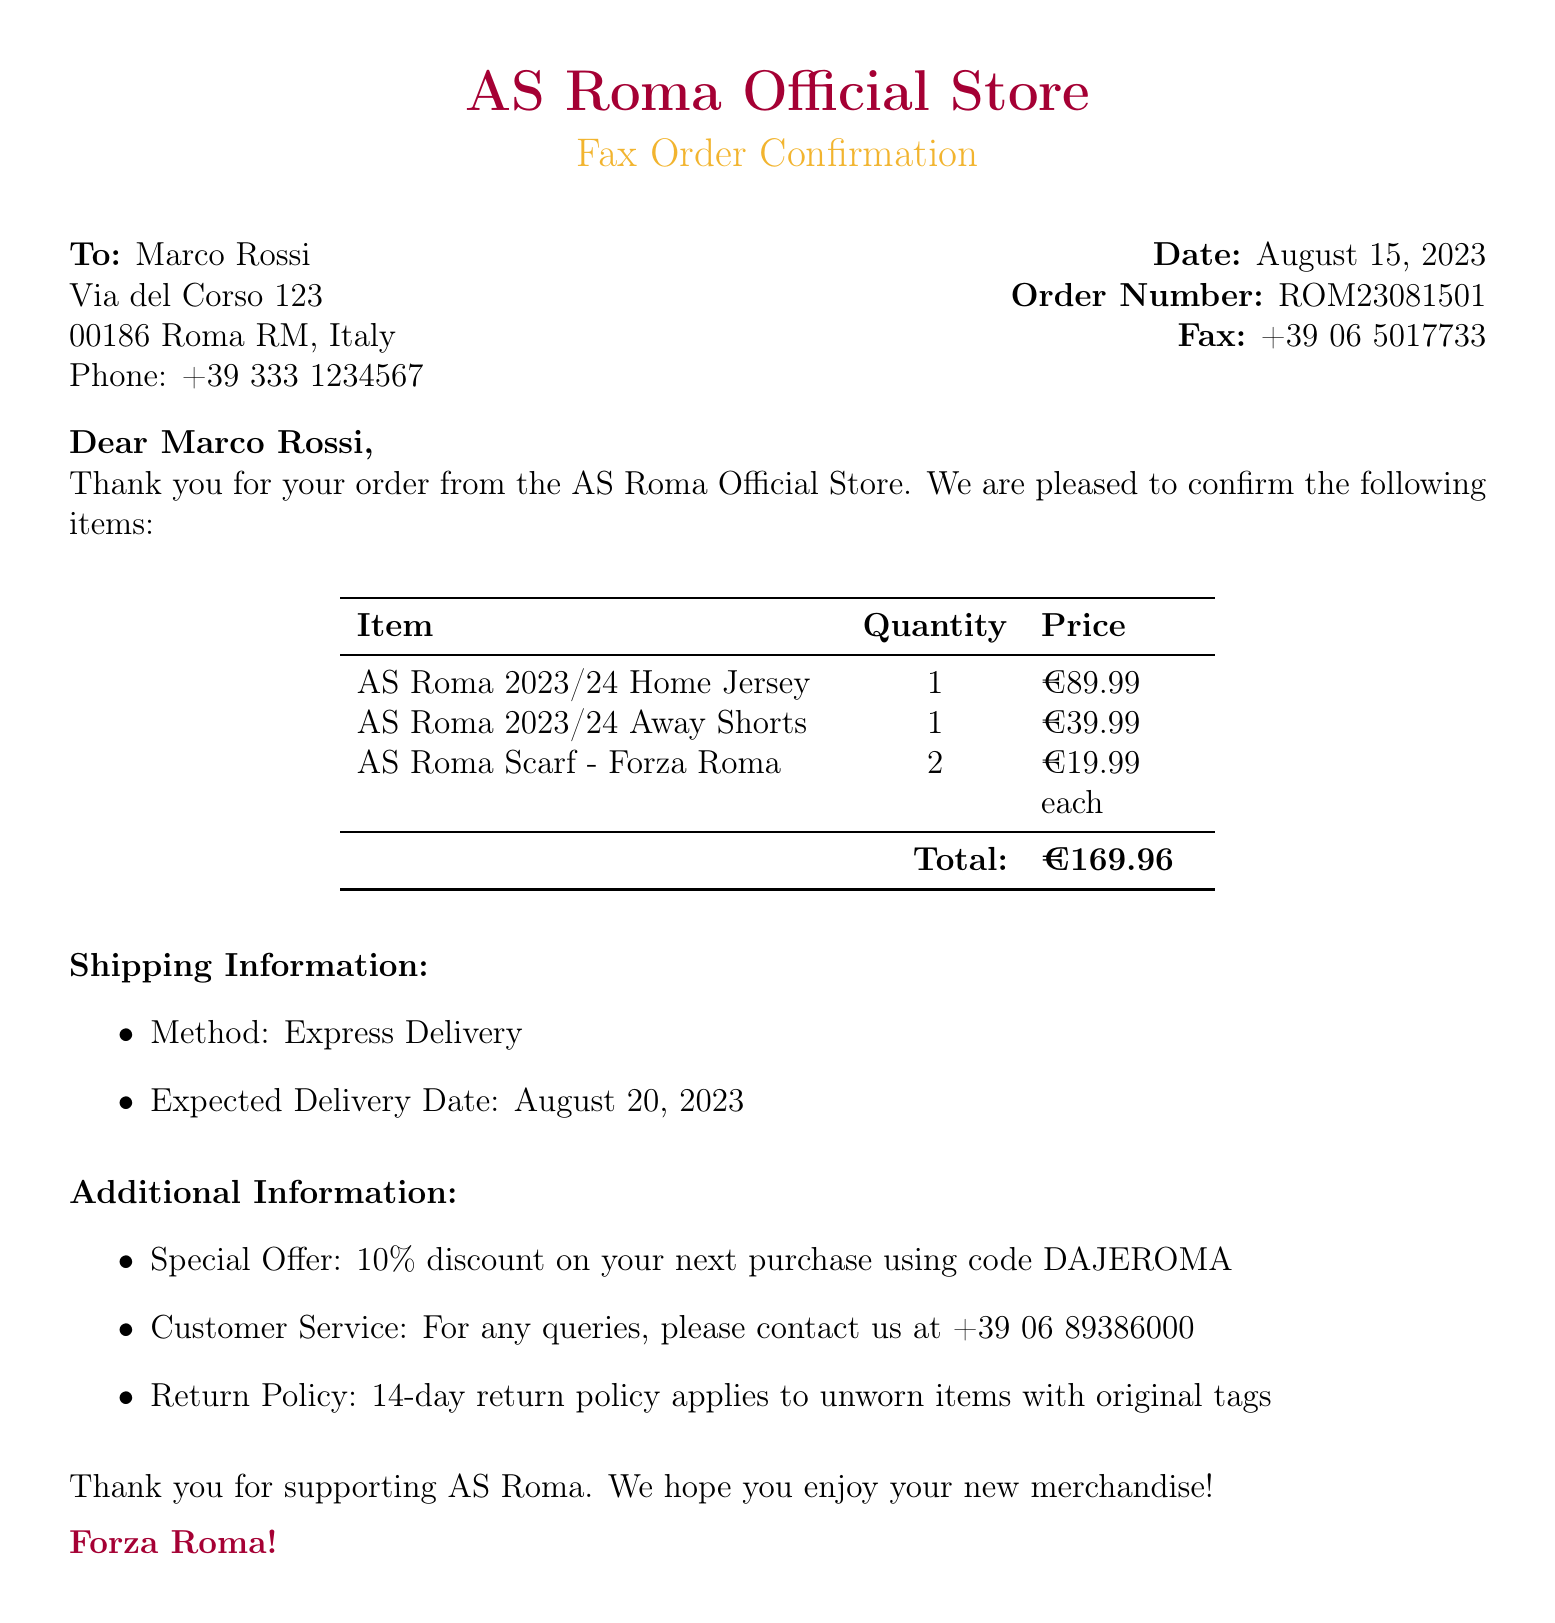What is the order number? The order number is a unique identifier assigned to the order, found in the document as "Order Number: ROM23081501".
Answer: ROM23081501 What items were purchased? The purchased items include the AS Roma 2023/24 Home Jersey, AS Roma 2023/24 Away Shorts, and AS Roma Scarf - Forza Roma, listed in the item table.
Answer: AS Roma 2023/24 Home Jersey, AS Roma 2023/24 Away Shorts, AS Roma Scarf - Forza Roma What is the total amount? The total amount is the sum of all item prices listed in the document, given as "Total: €169.96".
Answer: €169.96 When is the expected delivery date? The expected delivery date is stated in the shipping information section, specifying when the order will arrive.
Answer: August 20, 2023 How many AS Roma scarves were ordered? The quantity of AS Roma scarves is clearly stated in the item table under the quantity column.
Answer: 2 What discount code is provided for the next purchase? The discount code is mentioned in the additional information section, as a special offer for future orders.
Answer: DAJEROMA What is the shipping method? The shipping method is provided in the shipping information section as "Method: Express Delivery."
Answer: Express Delivery What is the return policy duration? The return policy duration is highlighted in the additional information section of the document.
Answer: 14-day 